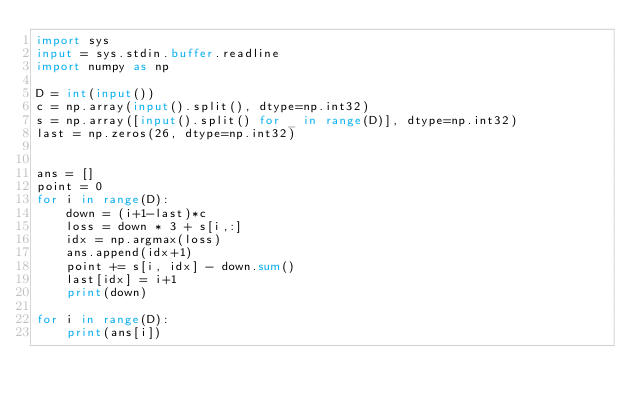<code> <loc_0><loc_0><loc_500><loc_500><_Python_>import sys
input = sys.stdin.buffer.readline
import numpy as np

D = int(input())
c = np.array(input().split(), dtype=np.int32)
s = np.array([input().split() for _ in range(D)], dtype=np.int32)
last = np.zeros(26, dtype=np.int32)


ans = []
point = 0
for i in range(D):
    down = (i+1-last)*c
    loss = down * 3 + s[i,:]
    idx = np.argmax(loss)
    ans.append(idx+1)
    point += s[i, idx] - down.sum()
    last[idx] = i+1
    print(down)
    
for i in range(D):
    print(ans[i])</code> 